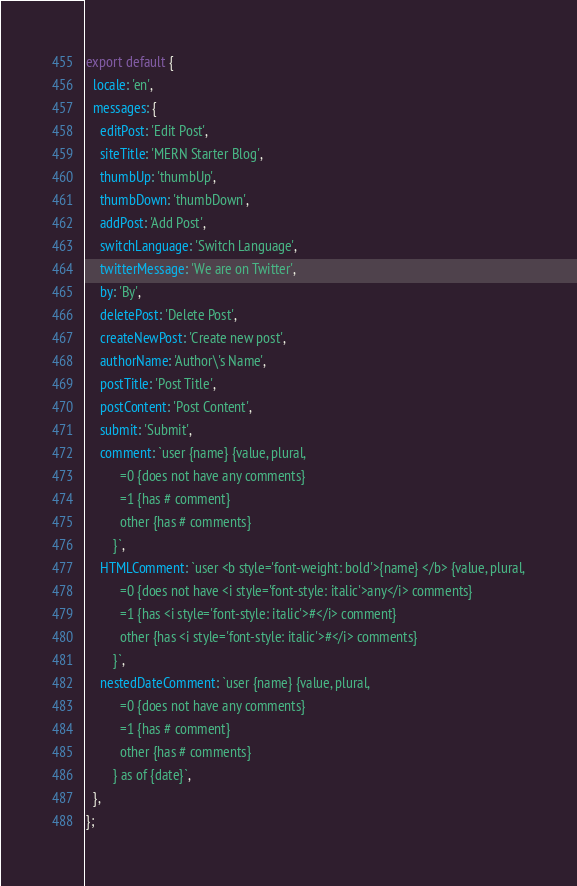Convert code to text. <code><loc_0><loc_0><loc_500><loc_500><_JavaScript_>
export default {
  locale: 'en',
  messages: {
    editPost: 'Edit Post',
    siteTitle: 'MERN Starter Blog',
    thumbUp: 'thumbUp',
    thumbDown: 'thumbDown',
    addPost: 'Add Post',
    switchLanguage: 'Switch Language',
    twitterMessage: 'We are on Twitter',
    by: 'By',
    deletePost: 'Delete Post',
    createNewPost: 'Create new post',
    authorName: 'Author\'s Name',
    postTitle: 'Post Title',
    postContent: 'Post Content',
    submit: 'Submit',
    comment: `user {name} {value, plural,
    	  =0 {does not have any comments}
    	  =1 {has # comment}
    	  other {has # comments}
    	}`,
    HTMLComment: `user <b style='font-weight: bold'>{name} </b> {value, plural,
    	  =0 {does not have <i style='font-style: italic'>any</i> comments}
    	  =1 {has <i style='font-style: italic'>#</i> comment}
    	  other {has <i style='font-style: italic'>#</i> comments}
    	}`,
    nestedDateComment: `user {name} {value, plural,
    	  =0 {does not have any comments}
    	  =1 {has # comment}
    	  other {has # comments}
    	} as of {date}`,
  },
};
</code> 